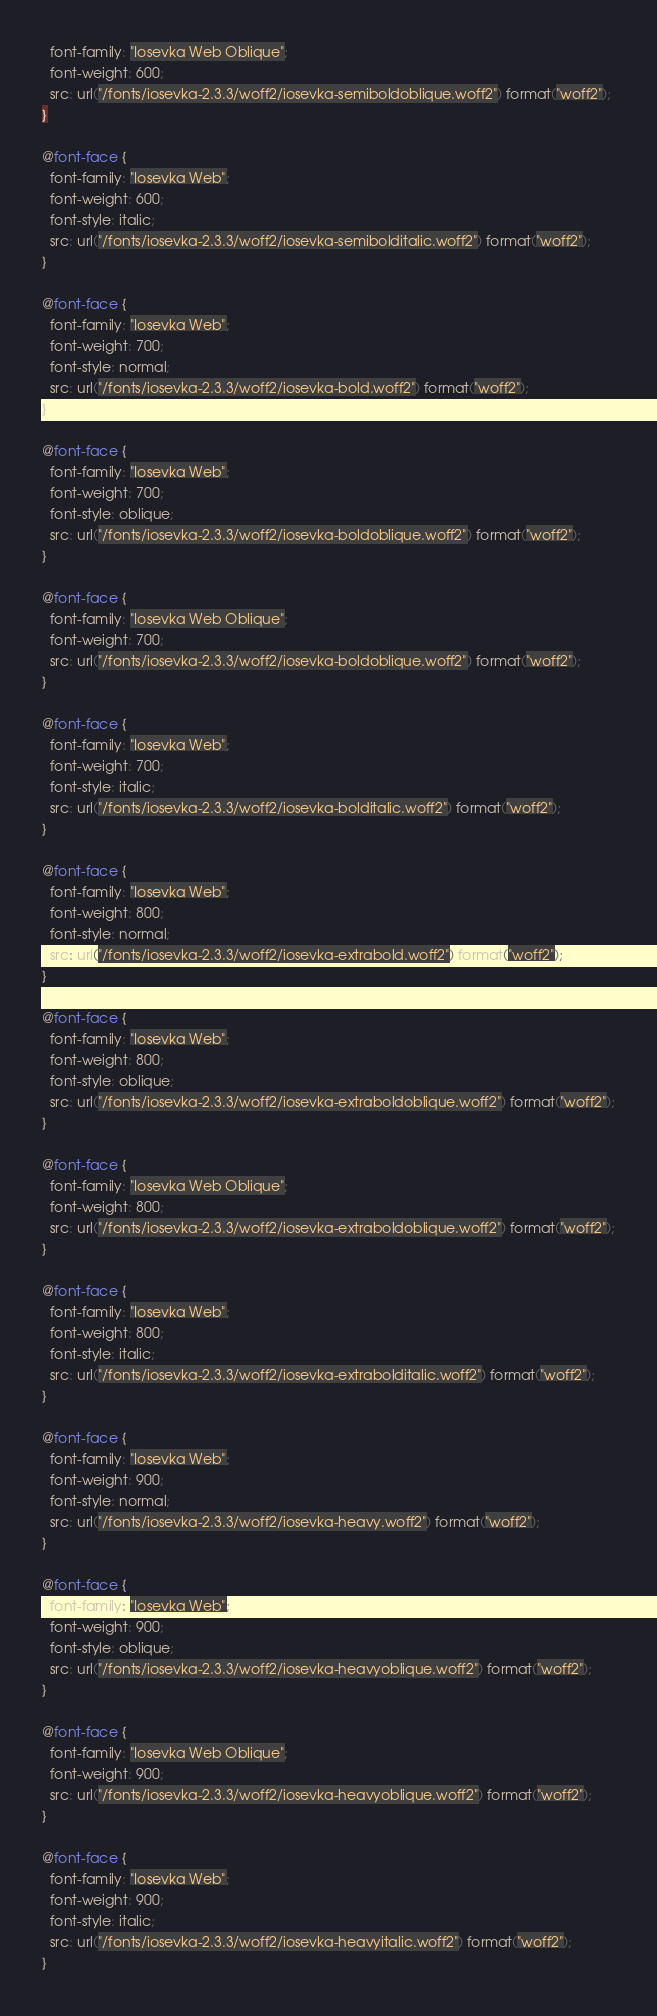<code> <loc_0><loc_0><loc_500><loc_500><_CSS_>  font-family: "Iosevka Web Oblique";
  font-weight: 600;
  src: url("/fonts/iosevka-2.3.3/woff2/iosevka-semiboldoblique.woff2") format("woff2");
}

@font-face {
  font-family: "Iosevka Web";
  font-weight: 600;
  font-style: italic;
  src: url("/fonts/iosevka-2.3.3/woff2/iosevka-semibolditalic.woff2") format("woff2");
}

@font-face {
  font-family: "Iosevka Web";
  font-weight: 700;
  font-style: normal;
  src: url("/fonts/iosevka-2.3.3/woff2/iosevka-bold.woff2") format("woff2");
}

@font-face {
  font-family: "Iosevka Web";
  font-weight: 700;
  font-style: oblique;
  src: url("/fonts/iosevka-2.3.3/woff2/iosevka-boldoblique.woff2") format("woff2");
}

@font-face {
  font-family: "Iosevka Web Oblique";
  font-weight: 700;
  src: url("/fonts/iosevka-2.3.3/woff2/iosevka-boldoblique.woff2") format("woff2");
}

@font-face {
  font-family: "Iosevka Web";
  font-weight: 700;
  font-style: italic;
  src: url("/fonts/iosevka-2.3.3/woff2/iosevka-bolditalic.woff2") format("woff2");
}

@font-face {
  font-family: "Iosevka Web";
  font-weight: 800;
  font-style: normal;
  src: url("/fonts/iosevka-2.3.3/woff2/iosevka-extrabold.woff2") format("woff2");
}

@font-face {
  font-family: "Iosevka Web";
  font-weight: 800;
  font-style: oblique;
  src: url("/fonts/iosevka-2.3.3/woff2/iosevka-extraboldoblique.woff2") format("woff2");
}

@font-face {
  font-family: "Iosevka Web Oblique";
  font-weight: 800;
  src: url("/fonts/iosevka-2.3.3/woff2/iosevka-extraboldoblique.woff2") format("woff2");
}

@font-face {
  font-family: "Iosevka Web";
  font-weight: 800;
  font-style: italic;
  src: url("/fonts/iosevka-2.3.3/woff2/iosevka-extrabolditalic.woff2") format("woff2");
}

@font-face {
  font-family: "Iosevka Web";
  font-weight: 900;
  font-style: normal;
  src: url("/fonts/iosevka-2.3.3/woff2/iosevka-heavy.woff2") format("woff2");
}

@font-face {
  font-family: "Iosevka Web";
  font-weight: 900;
  font-style: oblique;
  src: url("/fonts/iosevka-2.3.3/woff2/iosevka-heavyoblique.woff2") format("woff2");
}

@font-face {
  font-family: "Iosevka Web Oblique";
  font-weight: 900;
  src: url("/fonts/iosevka-2.3.3/woff2/iosevka-heavyoblique.woff2") format("woff2");
}

@font-face {
  font-family: "Iosevka Web";
  font-weight: 900;
  font-style: italic;
  src: url("/fonts/iosevka-2.3.3/woff2/iosevka-heavyitalic.woff2") format("woff2");
}
</code> 